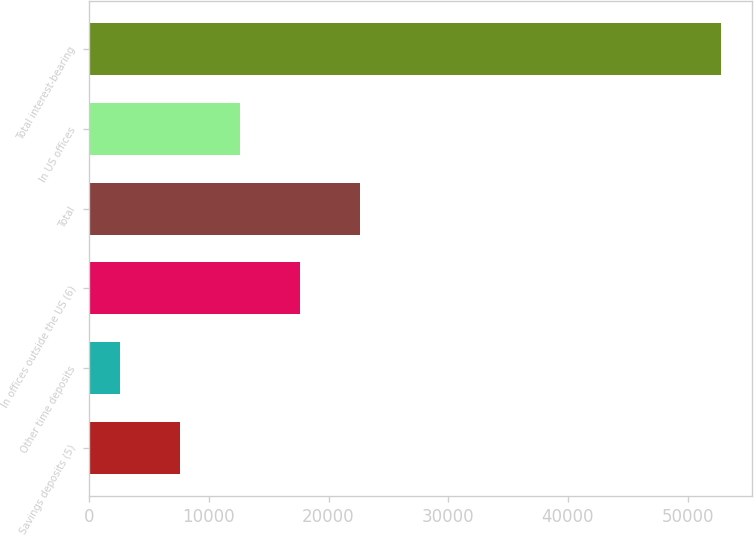Convert chart to OTSL. <chart><loc_0><loc_0><loc_500><loc_500><bar_chart><fcel>Savings deposits (5)<fcel>Other time deposits<fcel>In offices outside the US (6)<fcel>Total<fcel>In US offices<fcel>Total interest-bearing<nl><fcel>7618.6<fcel>2604<fcel>17647.8<fcel>22662.4<fcel>12633.2<fcel>52750<nl></chart> 